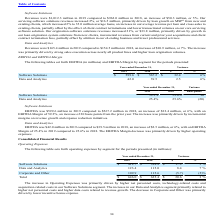According to Black Knight Financial Services's financial document, What was the main reason for the increase in Operating Expenses? higher net personnel costs, technology-related costs and acquisition-related costs in our Software Solutions segment.. The document states: "ease in Operating Expenses was primarily driven by higher net personnel costs, technology-related costs and acquisition-related costs in our Software ..." Also, What was the primary reason for the decrease in Corporate and Other? lower incentive bonus expense. The document states: "se in Corporate and Other was primarily driven by lower incentive bonus expense...." Also, Which years does the table provide information for the company's operating expenses by segment? The document shows two values: 2019 and 2018. From the document: "2019 2018 $ % 2019 2018 $ %..." Also, can you calculate: What was the difference in the percent variance between Software Solutions and Data and Analytics? Based on the calculation: 7-5, the result is 2 (percentage). This is based on the information: "million in 2018, an increase of $10.9 million, or 7%. The increase million in 2018, an increase of $50.3 million, or 5%. Our..." The key data points involved are: 5, 7. Also, can you calculate: What was the average revenue from Corporate and Other between 2018 and 2019? To answer this question, I need to perform calculations using the financial data. The calculation is: (109.9+115.6)/2, which equals 112.75 (in millions). This is based on the information: "Corporate and Other 109.9 115.6 (5.7) (5)% Corporate and Other 109.9 115.6 (5.7) (5)%..." The key data points involved are: 109.9, 115.6. Also, can you calculate: What was the average  operating expenses between 2018 and 2019? To answer this question, I need to perform calculations using the financial data. The calculation is: (646.0+625.4)/2, which equals 635.7 (in millions). This is based on the information: "Total $ 646.0 $ 625.4 $ 20.6 3 % Total $ 646.0 $ 625.4 $ 20.6 3 %..." The key data points involved are: 625.4, 646.0. 